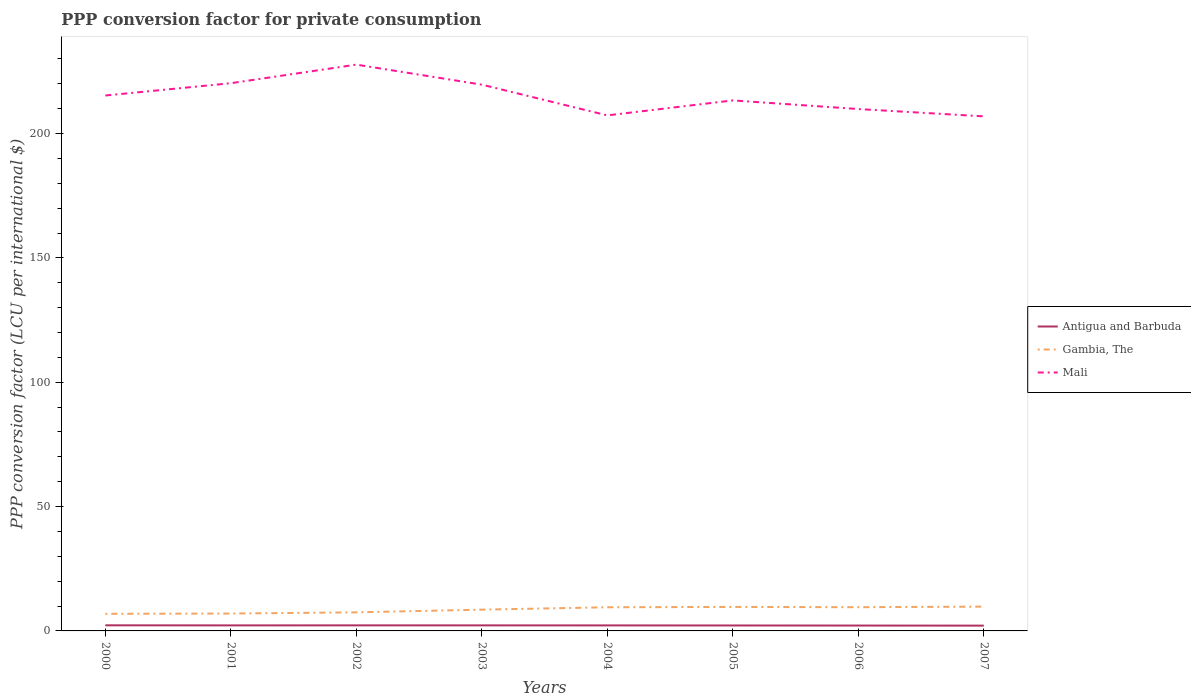Does the line corresponding to Gambia, The intersect with the line corresponding to Antigua and Barbuda?
Your answer should be compact. No. Is the number of lines equal to the number of legend labels?
Your answer should be compact. Yes. Across all years, what is the maximum PPP conversion factor for private consumption in Antigua and Barbuda?
Your answer should be very brief. 2.13. In which year was the PPP conversion factor for private consumption in Mali maximum?
Provide a succinct answer. 2007. What is the total PPP conversion factor for private consumption in Gambia, The in the graph?
Your answer should be very brief. -0.13. What is the difference between the highest and the second highest PPP conversion factor for private consumption in Gambia, The?
Keep it short and to the point. 2.89. What is the difference between two consecutive major ticks on the Y-axis?
Your answer should be very brief. 50. Where does the legend appear in the graph?
Your answer should be compact. Center right. How are the legend labels stacked?
Provide a short and direct response. Vertical. What is the title of the graph?
Offer a very short reply. PPP conversion factor for private consumption. What is the label or title of the X-axis?
Ensure brevity in your answer.  Years. What is the label or title of the Y-axis?
Offer a very short reply. PPP conversion factor (LCU per international $). What is the PPP conversion factor (LCU per international $) of Antigua and Barbuda in 2000?
Your answer should be compact. 2.25. What is the PPP conversion factor (LCU per international $) in Gambia, The in 2000?
Provide a succinct answer. 6.88. What is the PPP conversion factor (LCU per international $) of Mali in 2000?
Your answer should be compact. 215.3. What is the PPP conversion factor (LCU per international $) in Antigua and Barbuda in 2001?
Make the answer very short. 2.22. What is the PPP conversion factor (LCU per international $) in Gambia, The in 2001?
Keep it short and to the point. 6.99. What is the PPP conversion factor (LCU per international $) in Mali in 2001?
Your response must be concise. 220.24. What is the PPP conversion factor (LCU per international $) in Antigua and Barbuda in 2002?
Offer a terse response. 2.24. What is the PPP conversion factor (LCU per international $) in Gambia, The in 2002?
Your answer should be very brief. 7.47. What is the PPP conversion factor (LCU per international $) in Mali in 2002?
Provide a succinct answer. 227.71. What is the PPP conversion factor (LCU per international $) of Antigua and Barbuda in 2003?
Keep it short and to the point. 2.23. What is the PPP conversion factor (LCU per international $) of Gambia, The in 2003?
Provide a short and direct response. 8.55. What is the PPP conversion factor (LCU per international $) in Mali in 2003?
Provide a short and direct response. 219.66. What is the PPP conversion factor (LCU per international $) of Antigua and Barbuda in 2004?
Ensure brevity in your answer.  2.22. What is the PPP conversion factor (LCU per international $) in Gambia, The in 2004?
Provide a succinct answer. 9.51. What is the PPP conversion factor (LCU per international $) of Mali in 2004?
Your answer should be compact. 207.3. What is the PPP conversion factor (LCU per international $) of Antigua and Barbuda in 2005?
Ensure brevity in your answer.  2.19. What is the PPP conversion factor (LCU per international $) in Gambia, The in 2005?
Provide a short and direct response. 9.65. What is the PPP conversion factor (LCU per international $) of Mali in 2005?
Provide a succinct answer. 213.32. What is the PPP conversion factor (LCU per international $) of Antigua and Barbuda in 2006?
Ensure brevity in your answer.  2.16. What is the PPP conversion factor (LCU per international $) in Gambia, The in 2006?
Provide a short and direct response. 9.54. What is the PPP conversion factor (LCU per international $) of Mali in 2006?
Your response must be concise. 209.85. What is the PPP conversion factor (LCU per international $) of Antigua and Barbuda in 2007?
Your response must be concise. 2.13. What is the PPP conversion factor (LCU per international $) of Gambia, The in 2007?
Make the answer very short. 9.77. What is the PPP conversion factor (LCU per international $) in Mali in 2007?
Provide a short and direct response. 206.91. Across all years, what is the maximum PPP conversion factor (LCU per international $) in Antigua and Barbuda?
Make the answer very short. 2.25. Across all years, what is the maximum PPP conversion factor (LCU per international $) in Gambia, The?
Offer a very short reply. 9.77. Across all years, what is the maximum PPP conversion factor (LCU per international $) of Mali?
Offer a terse response. 227.71. Across all years, what is the minimum PPP conversion factor (LCU per international $) in Antigua and Barbuda?
Provide a succinct answer. 2.13. Across all years, what is the minimum PPP conversion factor (LCU per international $) in Gambia, The?
Your answer should be very brief. 6.88. Across all years, what is the minimum PPP conversion factor (LCU per international $) of Mali?
Your answer should be very brief. 206.91. What is the total PPP conversion factor (LCU per international $) of Antigua and Barbuda in the graph?
Ensure brevity in your answer.  17.65. What is the total PPP conversion factor (LCU per international $) of Gambia, The in the graph?
Give a very brief answer. 68.36. What is the total PPP conversion factor (LCU per international $) of Mali in the graph?
Offer a very short reply. 1720.28. What is the difference between the PPP conversion factor (LCU per international $) of Antigua and Barbuda in 2000 and that in 2001?
Ensure brevity in your answer.  0.03. What is the difference between the PPP conversion factor (LCU per international $) of Gambia, The in 2000 and that in 2001?
Ensure brevity in your answer.  -0.11. What is the difference between the PPP conversion factor (LCU per international $) in Mali in 2000 and that in 2001?
Your response must be concise. -4.94. What is the difference between the PPP conversion factor (LCU per international $) in Antigua and Barbuda in 2000 and that in 2002?
Ensure brevity in your answer.  0.01. What is the difference between the PPP conversion factor (LCU per international $) in Gambia, The in 2000 and that in 2002?
Your answer should be compact. -0.59. What is the difference between the PPP conversion factor (LCU per international $) in Mali in 2000 and that in 2002?
Your answer should be compact. -12.42. What is the difference between the PPP conversion factor (LCU per international $) in Antigua and Barbuda in 2000 and that in 2003?
Give a very brief answer. 0.02. What is the difference between the PPP conversion factor (LCU per international $) of Gambia, The in 2000 and that in 2003?
Your answer should be compact. -1.67. What is the difference between the PPP conversion factor (LCU per international $) in Mali in 2000 and that in 2003?
Offer a very short reply. -4.36. What is the difference between the PPP conversion factor (LCU per international $) in Antigua and Barbuda in 2000 and that in 2004?
Provide a short and direct response. 0.03. What is the difference between the PPP conversion factor (LCU per international $) in Gambia, The in 2000 and that in 2004?
Provide a short and direct response. -2.63. What is the difference between the PPP conversion factor (LCU per international $) of Mali in 2000 and that in 2004?
Give a very brief answer. 8. What is the difference between the PPP conversion factor (LCU per international $) in Antigua and Barbuda in 2000 and that in 2005?
Your response must be concise. 0.06. What is the difference between the PPP conversion factor (LCU per international $) in Gambia, The in 2000 and that in 2005?
Make the answer very short. -2.77. What is the difference between the PPP conversion factor (LCU per international $) of Mali in 2000 and that in 2005?
Give a very brief answer. 1.97. What is the difference between the PPP conversion factor (LCU per international $) in Antigua and Barbuda in 2000 and that in 2006?
Keep it short and to the point. 0.09. What is the difference between the PPP conversion factor (LCU per international $) in Gambia, The in 2000 and that in 2006?
Provide a short and direct response. -2.66. What is the difference between the PPP conversion factor (LCU per international $) of Mali in 2000 and that in 2006?
Ensure brevity in your answer.  5.45. What is the difference between the PPP conversion factor (LCU per international $) in Antigua and Barbuda in 2000 and that in 2007?
Offer a terse response. 0.12. What is the difference between the PPP conversion factor (LCU per international $) of Gambia, The in 2000 and that in 2007?
Keep it short and to the point. -2.89. What is the difference between the PPP conversion factor (LCU per international $) in Mali in 2000 and that in 2007?
Ensure brevity in your answer.  8.39. What is the difference between the PPP conversion factor (LCU per international $) in Antigua and Barbuda in 2001 and that in 2002?
Your answer should be very brief. -0.02. What is the difference between the PPP conversion factor (LCU per international $) in Gambia, The in 2001 and that in 2002?
Ensure brevity in your answer.  -0.48. What is the difference between the PPP conversion factor (LCU per international $) of Mali in 2001 and that in 2002?
Your answer should be very brief. -7.47. What is the difference between the PPP conversion factor (LCU per international $) of Antigua and Barbuda in 2001 and that in 2003?
Make the answer very short. -0.01. What is the difference between the PPP conversion factor (LCU per international $) of Gambia, The in 2001 and that in 2003?
Keep it short and to the point. -1.56. What is the difference between the PPP conversion factor (LCU per international $) in Mali in 2001 and that in 2003?
Keep it short and to the point. 0.58. What is the difference between the PPP conversion factor (LCU per international $) of Antigua and Barbuda in 2001 and that in 2004?
Ensure brevity in your answer.  0. What is the difference between the PPP conversion factor (LCU per international $) of Gambia, The in 2001 and that in 2004?
Make the answer very short. -2.52. What is the difference between the PPP conversion factor (LCU per international $) of Mali in 2001 and that in 2004?
Offer a very short reply. 12.94. What is the difference between the PPP conversion factor (LCU per international $) in Antigua and Barbuda in 2001 and that in 2005?
Your answer should be very brief. 0.03. What is the difference between the PPP conversion factor (LCU per international $) of Gambia, The in 2001 and that in 2005?
Your answer should be very brief. -2.66. What is the difference between the PPP conversion factor (LCU per international $) in Mali in 2001 and that in 2005?
Make the answer very short. 6.91. What is the difference between the PPP conversion factor (LCU per international $) of Antigua and Barbuda in 2001 and that in 2006?
Give a very brief answer. 0.06. What is the difference between the PPP conversion factor (LCU per international $) of Gambia, The in 2001 and that in 2006?
Keep it short and to the point. -2.55. What is the difference between the PPP conversion factor (LCU per international $) of Mali in 2001 and that in 2006?
Ensure brevity in your answer.  10.39. What is the difference between the PPP conversion factor (LCU per international $) of Antigua and Barbuda in 2001 and that in 2007?
Your answer should be very brief. 0.09. What is the difference between the PPP conversion factor (LCU per international $) of Gambia, The in 2001 and that in 2007?
Your answer should be compact. -2.78. What is the difference between the PPP conversion factor (LCU per international $) in Mali in 2001 and that in 2007?
Provide a short and direct response. 13.33. What is the difference between the PPP conversion factor (LCU per international $) of Antigua and Barbuda in 2002 and that in 2003?
Keep it short and to the point. 0.01. What is the difference between the PPP conversion factor (LCU per international $) of Gambia, The in 2002 and that in 2003?
Your answer should be compact. -1.08. What is the difference between the PPP conversion factor (LCU per international $) of Mali in 2002 and that in 2003?
Offer a very short reply. 8.05. What is the difference between the PPP conversion factor (LCU per international $) of Antigua and Barbuda in 2002 and that in 2004?
Your answer should be compact. 0.02. What is the difference between the PPP conversion factor (LCU per international $) of Gambia, The in 2002 and that in 2004?
Your answer should be very brief. -2.04. What is the difference between the PPP conversion factor (LCU per international $) of Mali in 2002 and that in 2004?
Your answer should be very brief. 20.41. What is the difference between the PPP conversion factor (LCU per international $) in Antigua and Barbuda in 2002 and that in 2005?
Give a very brief answer. 0.05. What is the difference between the PPP conversion factor (LCU per international $) of Gambia, The in 2002 and that in 2005?
Provide a short and direct response. -2.17. What is the difference between the PPP conversion factor (LCU per international $) in Mali in 2002 and that in 2005?
Give a very brief answer. 14.39. What is the difference between the PPP conversion factor (LCU per international $) in Antigua and Barbuda in 2002 and that in 2006?
Provide a succinct answer. 0.08. What is the difference between the PPP conversion factor (LCU per international $) in Gambia, The in 2002 and that in 2006?
Give a very brief answer. -2.06. What is the difference between the PPP conversion factor (LCU per international $) of Mali in 2002 and that in 2006?
Provide a succinct answer. 17.86. What is the difference between the PPP conversion factor (LCU per international $) of Antigua and Barbuda in 2002 and that in 2007?
Your answer should be very brief. 0.11. What is the difference between the PPP conversion factor (LCU per international $) in Gambia, The in 2002 and that in 2007?
Offer a terse response. -2.3. What is the difference between the PPP conversion factor (LCU per international $) in Mali in 2002 and that in 2007?
Keep it short and to the point. 20.8. What is the difference between the PPP conversion factor (LCU per international $) in Antigua and Barbuda in 2003 and that in 2004?
Your answer should be very brief. 0.01. What is the difference between the PPP conversion factor (LCU per international $) of Gambia, The in 2003 and that in 2004?
Offer a very short reply. -0.96. What is the difference between the PPP conversion factor (LCU per international $) in Mali in 2003 and that in 2004?
Provide a short and direct response. 12.36. What is the difference between the PPP conversion factor (LCU per international $) in Antigua and Barbuda in 2003 and that in 2005?
Provide a succinct answer. 0.04. What is the difference between the PPP conversion factor (LCU per international $) in Gambia, The in 2003 and that in 2005?
Provide a short and direct response. -1.09. What is the difference between the PPP conversion factor (LCU per international $) in Mali in 2003 and that in 2005?
Your answer should be very brief. 6.33. What is the difference between the PPP conversion factor (LCU per international $) in Antigua and Barbuda in 2003 and that in 2006?
Your response must be concise. 0.07. What is the difference between the PPP conversion factor (LCU per international $) of Gambia, The in 2003 and that in 2006?
Make the answer very short. -0.98. What is the difference between the PPP conversion factor (LCU per international $) of Mali in 2003 and that in 2006?
Provide a short and direct response. 9.81. What is the difference between the PPP conversion factor (LCU per international $) in Antigua and Barbuda in 2003 and that in 2007?
Your answer should be compact. 0.1. What is the difference between the PPP conversion factor (LCU per international $) in Gambia, The in 2003 and that in 2007?
Provide a short and direct response. -1.22. What is the difference between the PPP conversion factor (LCU per international $) in Mali in 2003 and that in 2007?
Give a very brief answer. 12.75. What is the difference between the PPP conversion factor (LCU per international $) of Antigua and Barbuda in 2004 and that in 2005?
Ensure brevity in your answer.  0.03. What is the difference between the PPP conversion factor (LCU per international $) of Gambia, The in 2004 and that in 2005?
Provide a short and direct response. -0.13. What is the difference between the PPP conversion factor (LCU per international $) of Mali in 2004 and that in 2005?
Make the answer very short. -6.03. What is the difference between the PPP conversion factor (LCU per international $) of Antigua and Barbuda in 2004 and that in 2006?
Keep it short and to the point. 0.06. What is the difference between the PPP conversion factor (LCU per international $) in Gambia, The in 2004 and that in 2006?
Provide a short and direct response. -0.02. What is the difference between the PPP conversion factor (LCU per international $) of Mali in 2004 and that in 2006?
Make the answer very short. -2.55. What is the difference between the PPP conversion factor (LCU per international $) of Antigua and Barbuda in 2004 and that in 2007?
Give a very brief answer. 0.09. What is the difference between the PPP conversion factor (LCU per international $) of Gambia, The in 2004 and that in 2007?
Keep it short and to the point. -0.26. What is the difference between the PPP conversion factor (LCU per international $) in Mali in 2004 and that in 2007?
Provide a succinct answer. 0.39. What is the difference between the PPP conversion factor (LCU per international $) in Antigua and Barbuda in 2005 and that in 2006?
Ensure brevity in your answer.  0.03. What is the difference between the PPP conversion factor (LCU per international $) of Gambia, The in 2005 and that in 2006?
Provide a succinct answer. 0.11. What is the difference between the PPP conversion factor (LCU per international $) in Mali in 2005 and that in 2006?
Your answer should be compact. 3.48. What is the difference between the PPP conversion factor (LCU per international $) of Antigua and Barbuda in 2005 and that in 2007?
Offer a very short reply. 0.06. What is the difference between the PPP conversion factor (LCU per international $) in Gambia, The in 2005 and that in 2007?
Ensure brevity in your answer.  -0.12. What is the difference between the PPP conversion factor (LCU per international $) of Mali in 2005 and that in 2007?
Your answer should be compact. 6.42. What is the difference between the PPP conversion factor (LCU per international $) in Antigua and Barbuda in 2006 and that in 2007?
Ensure brevity in your answer.  0.03. What is the difference between the PPP conversion factor (LCU per international $) of Gambia, The in 2006 and that in 2007?
Your response must be concise. -0.23. What is the difference between the PPP conversion factor (LCU per international $) in Mali in 2006 and that in 2007?
Give a very brief answer. 2.94. What is the difference between the PPP conversion factor (LCU per international $) in Antigua and Barbuda in 2000 and the PPP conversion factor (LCU per international $) in Gambia, The in 2001?
Offer a very short reply. -4.74. What is the difference between the PPP conversion factor (LCU per international $) of Antigua and Barbuda in 2000 and the PPP conversion factor (LCU per international $) of Mali in 2001?
Offer a terse response. -217.99. What is the difference between the PPP conversion factor (LCU per international $) in Gambia, The in 2000 and the PPP conversion factor (LCU per international $) in Mali in 2001?
Make the answer very short. -213.36. What is the difference between the PPP conversion factor (LCU per international $) of Antigua and Barbuda in 2000 and the PPP conversion factor (LCU per international $) of Gambia, The in 2002?
Your answer should be very brief. -5.22. What is the difference between the PPP conversion factor (LCU per international $) of Antigua and Barbuda in 2000 and the PPP conversion factor (LCU per international $) of Mali in 2002?
Offer a terse response. -225.46. What is the difference between the PPP conversion factor (LCU per international $) of Gambia, The in 2000 and the PPP conversion factor (LCU per international $) of Mali in 2002?
Your response must be concise. -220.83. What is the difference between the PPP conversion factor (LCU per international $) of Antigua and Barbuda in 2000 and the PPP conversion factor (LCU per international $) of Gambia, The in 2003?
Make the answer very short. -6.3. What is the difference between the PPP conversion factor (LCU per international $) of Antigua and Barbuda in 2000 and the PPP conversion factor (LCU per international $) of Mali in 2003?
Give a very brief answer. -217.41. What is the difference between the PPP conversion factor (LCU per international $) of Gambia, The in 2000 and the PPP conversion factor (LCU per international $) of Mali in 2003?
Your response must be concise. -212.78. What is the difference between the PPP conversion factor (LCU per international $) of Antigua and Barbuda in 2000 and the PPP conversion factor (LCU per international $) of Gambia, The in 2004?
Provide a short and direct response. -7.26. What is the difference between the PPP conversion factor (LCU per international $) of Antigua and Barbuda in 2000 and the PPP conversion factor (LCU per international $) of Mali in 2004?
Offer a very short reply. -205.05. What is the difference between the PPP conversion factor (LCU per international $) of Gambia, The in 2000 and the PPP conversion factor (LCU per international $) of Mali in 2004?
Offer a terse response. -200.42. What is the difference between the PPP conversion factor (LCU per international $) in Antigua and Barbuda in 2000 and the PPP conversion factor (LCU per international $) in Gambia, The in 2005?
Offer a terse response. -7.39. What is the difference between the PPP conversion factor (LCU per international $) of Antigua and Barbuda in 2000 and the PPP conversion factor (LCU per international $) of Mali in 2005?
Your answer should be compact. -211.07. What is the difference between the PPP conversion factor (LCU per international $) in Gambia, The in 2000 and the PPP conversion factor (LCU per international $) in Mali in 2005?
Provide a succinct answer. -206.45. What is the difference between the PPP conversion factor (LCU per international $) in Antigua and Barbuda in 2000 and the PPP conversion factor (LCU per international $) in Gambia, The in 2006?
Give a very brief answer. -7.28. What is the difference between the PPP conversion factor (LCU per international $) of Antigua and Barbuda in 2000 and the PPP conversion factor (LCU per international $) of Mali in 2006?
Your response must be concise. -207.6. What is the difference between the PPP conversion factor (LCU per international $) of Gambia, The in 2000 and the PPP conversion factor (LCU per international $) of Mali in 2006?
Keep it short and to the point. -202.97. What is the difference between the PPP conversion factor (LCU per international $) of Antigua and Barbuda in 2000 and the PPP conversion factor (LCU per international $) of Gambia, The in 2007?
Offer a very short reply. -7.52. What is the difference between the PPP conversion factor (LCU per international $) in Antigua and Barbuda in 2000 and the PPP conversion factor (LCU per international $) in Mali in 2007?
Provide a succinct answer. -204.66. What is the difference between the PPP conversion factor (LCU per international $) of Gambia, The in 2000 and the PPP conversion factor (LCU per international $) of Mali in 2007?
Offer a terse response. -200.03. What is the difference between the PPP conversion factor (LCU per international $) of Antigua and Barbuda in 2001 and the PPP conversion factor (LCU per international $) of Gambia, The in 2002?
Your answer should be compact. -5.25. What is the difference between the PPP conversion factor (LCU per international $) in Antigua and Barbuda in 2001 and the PPP conversion factor (LCU per international $) in Mali in 2002?
Your answer should be very brief. -225.49. What is the difference between the PPP conversion factor (LCU per international $) in Gambia, The in 2001 and the PPP conversion factor (LCU per international $) in Mali in 2002?
Ensure brevity in your answer.  -220.72. What is the difference between the PPP conversion factor (LCU per international $) of Antigua and Barbuda in 2001 and the PPP conversion factor (LCU per international $) of Gambia, The in 2003?
Offer a very short reply. -6.33. What is the difference between the PPP conversion factor (LCU per international $) of Antigua and Barbuda in 2001 and the PPP conversion factor (LCU per international $) of Mali in 2003?
Ensure brevity in your answer.  -217.44. What is the difference between the PPP conversion factor (LCU per international $) in Gambia, The in 2001 and the PPP conversion factor (LCU per international $) in Mali in 2003?
Your answer should be very brief. -212.67. What is the difference between the PPP conversion factor (LCU per international $) in Antigua and Barbuda in 2001 and the PPP conversion factor (LCU per international $) in Gambia, The in 2004?
Offer a very short reply. -7.29. What is the difference between the PPP conversion factor (LCU per international $) of Antigua and Barbuda in 2001 and the PPP conversion factor (LCU per international $) of Mali in 2004?
Give a very brief answer. -205.08. What is the difference between the PPP conversion factor (LCU per international $) of Gambia, The in 2001 and the PPP conversion factor (LCU per international $) of Mali in 2004?
Your response must be concise. -200.31. What is the difference between the PPP conversion factor (LCU per international $) of Antigua and Barbuda in 2001 and the PPP conversion factor (LCU per international $) of Gambia, The in 2005?
Keep it short and to the point. -7.42. What is the difference between the PPP conversion factor (LCU per international $) in Antigua and Barbuda in 2001 and the PPP conversion factor (LCU per international $) in Mali in 2005?
Provide a succinct answer. -211.1. What is the difference between the PPP conversion factor (LCU per international $) of Gambia, The in 2001 and the PPP conversion factor (LCU per international $) of Mali in 2005?
Offer a terse response. -206.33. What is the difference between the PPP conversion factor (LCU per international $) of Antigua and Barbuda in 2001 and the PPP conversion factor (LCU per international $) of Gambia, The in 2006?
Provide a succinct answer. -7.32. What is the difference between the PPP conversion factor (LCU per international $) in Antigua and Barbuda in 2001 and the PPP conversion factor (LCU per international $) in Mali in 2006?
Provide a succinct answer. -207.63. What is the difference between the PPP conversion factor (LCU per international $) in Gambia, The in 2001 and the PPP conversion factor (LCU per international $) in Mali in 2006?
Provide a succinct answer. -202.86. What is the difference between the PPP conversion factor (LCU per international $) of Antigua and Barbuda in 2001 and the PPP conversion factor (LCU per international $) of Gambia, The in 2007?
Offer a very short reply. -7.55. What is the difference between the PPP conversion factor (LCU per international $) of Antigua and Barbuda in 2001 and the PPP conversion factor (LCU per international $) of Mali in 2007?
Give a very brief answer. -204.69. What is the difference between the PPP conversion factor (LCU per international $) in Gambia, The in 2001 and the PPP conversion factor (LCU per international $) in Mali in 2007?
Give a very brief answer. -199.92. What is the difference between the PPP conversion factor (LCU per international $) in Antigua and Barbuda in 2002 and the PPP conversion factor (LCU per international $) in Gambia, The in 2003?
Your answer should be very brief. -6.31. What is the difference between the PPP conversion factor (LCU per international $) of Antigua and Barbuda in 2002 and the PPP conversion factor (LCU per international $) of Mali in 2003?
Give a very brief answer. -217.42. What is the difference between the PPP conversion factor (LCU per international $) of Gambia, The in 2002 and the PPP conversion factor (LCU per international $) of Mali in 2003?
Offer a very short reply. -212.18. What is the difference between the PPP conversion factor (LCU per international $) in Antigua and Barbuda in 2002 and the PPP conversion factor (LCU per international $) in Gambia, The in 2004?
Provide a short and direct response. -7.27. What is the difference between the PPP conversion factor (LCU per international $) in Antigua and Barbuda in 2002 and the PPP conversion factor (LCU per international $) in Mali in 2004?
Provide a short and direct response. -205.06. What is the difference between the PPP conversion factor (LCU per international $) in Gambia, The in 2002 and the PPP conversion factor (LCU per international $) in Mali in 2004?
Provide a succinct answer. -199.83. What is the difference between the PPP conversion factor (LCU per international $) in Antigua and Barbuda in 2002 and the PPP conversion factor (LCU per international $) in Gambia, The in 2005?
Your response must be concise. -7.41. What is the difference between the PPP conversion factor (LCU per international $) in Antigua and Barbuda in 2002 and the PPP conversion factor (LCU per international $) in Mali in 2005?
Offer a terse response. -211.09. What is the difference between the PPP conversion factor (LCU per international $) of Gambia, The in 2002 and the PPP conversion factor (LCU per international $) of Mali in 2005?
Offer a terse response. -205.85. What is the difference between the PPP conversion factor (LCU per international $) of Antigua and Barbuda in 2002 and the PPP conversion factor (LCU per international $) of Gambia, The in 2006?
Your response must be concise. -7.3. What is the difference between the PPP conversion factor (LCU per international $) of Antigua and Barbuda in 2002 and the PPP conversion factor (LCU per international $) of Mali in 2006?
Offer a terse response. -207.61. What is the difference between the PPP conversion factor (LCU per international $) of Gambia, The in 2002 and the PPP conversion factor (LCU per international $) of Mali in 2006?
Offer a very short reply. -202.37. What is the difference between the PPP conversion factor (LCU per international $) in Antigua and Barbuda in 2002 and the PPP conversion factor (LCU per international $) in Gambia, The in 2007?
Keep it short and to the point. -7.53. What is the difference between the PPP conversion factor (LCU per international $) in Antigua and Barbuda in 2002 and the PPP conversion factor (LCU per international $) in Mali in 2007?
Keep it short and to the point. -204.67. What is the difference between the PPP conversion factor (LCU per international $) in Gambia, The in 2002 and the PPP conversion factor (LCU per international $) in Mali in 2007?
Offer a terse response. -199.43. What is the difference between the PPP conversion factor (LCU per international $) of Antigua and Barbuda in 2003 and the PPP conversion factor (LCU per international $) of Gambia, The in 2004?
Offer a very short reply. -7.28. What is the difference between the PPP conversion factor (LCU per international $) of Antigua and Barbuda in 2003 and the PPP conversion factor (LCU per international $) of Mali in 2004?
Offer a terse response. -205.07. What is the difference between the PPP conversion factor (LCU per international $) in Gambia, The in 2003 and the PPP conversion factor (LCU per international $) in Mali in 2004?
Provide a short and direct response. -198.75. What is the difference between the PPP conversion factor (LCU per international $) of Antigua and Barbuda in 2003 and the PPP conversion factor (LCU per international $) of Gambia, The in 2005?
Ensure brevity in your answer.  -7.41. What is the difference between the PPP conversion factor (LCU per international $) of Antigua and Barbuda in 2003 and the PPP conversion factor (LCU per international $) of Mali in 2005?
Offer a terse response. -211.09. What is the difference between the PPP conversion factor (LCU per international $) in Gambia, The in 2003 and the PPP conversion factor (LCU per international $) in Mali in 2005?
Your response must be concise. -204.77. What is the difference between the PPP conversion factor (LCU per international $) of Antigua and Barbuda in 2003 and the PPP conversion factor (LCU per international $) of Gambia, The in 2006?
Offer a very short reply. -7.3. What is the difference between the PPP conversion factor (LCU per international $) of Antigua and Barbuda in 2003 and the PPP conversion factor (LCU per international $) of Mali in 2006?
Your response must be concise. -207.61. What is the difference between the PPP conversion factor (LCU per international $) of Gambia, The in 2003 and the PPP conversion factor (LCU per international $) of Mali in 2006?
Your response must be concise. -201.3. What is the difference between the PPP conversion factor (LCU per international $) of Antigua and Barbuda in 2003 and the PPP conversion factor (LCU per international $) of Gambia, The in 2007?
Your answer should be very brief. -7.54. What is the difference between the PPP conversion factor (LCU per international $) of Antigua and Barbuda in 2003 and the PPP conversion factor (LCU per international $) of Mali in 2007?
Give a very brief answer. -204.68. What is the difference between the PPP conversion factor (LCU per international $) of Gambia, The in 2003 and the PPP conversion factor (LCU per international $) of Mali in 2007?
Your answer should be compact. -198.36. What is the difference between the PPP conversion factor (LCU per international $) of Antigua and Barbuda in 2004 and the PPP conversion factor (LCU per international $) of Gambia, The in 2005?
Your answer should be compact. -7.43. What is the difference between the PPP conversion factor (LCU per international $) in Antigua and Barbuda in 2004 and the PPP conversion factor (LCU per international $) in Mali in 2005?
Give a very brief answer. -211.11. What is the difference between the PPP conversion factor (LCU per international $) of Gambia, The in 2004 and the PPP conversion factor (LCU per international $) of Mali in 2005?
Offer a very short reply. -203.81. What is the difference between the PPP conversion factor (LCU per international $) of Antigua and Barbuda in 2004 and the PPP conversion factor (LCU per international $) of Gambia, The in 2006?
Keep it short and to the point. -7.32. What is the difference between the PPP conversion factor (LCU per international $) in Antigua and Barbuda in 2004 and the PPP conversion factor (LCU per international $) in Mali in 2006?
Your answer should be very brief. -207.63. What is the difference between the PPP conversion factor (LCU per international $) in Gambia, The in 2004 and the PPP conversion factor (LCU per international $) in Mali in 2006?
Your answer should be very brief. -200.34. What is the difference between the PPP conversion factor (LCU per international $) of Antigua and Barbuda in 2004 and the PPP conversion factor (LCU per international $) of Gambia, The in 2007?
Your answer should be compact. -7.55. What is the difference between the PPP conversion factor (LCU per international $) in Antigua and Barbuda in 2004 and the PPP conversion factor (LCU per international $) in Mali in 2007?
Give a very brief answer. -204.69. What is the difference between the PPP conversion factor (LCU per international $) of Gambia, The in 2004 and the PPP conversion factor (LCU per international $) of Mali in 2007?
Provide a succinct answer. -197.4. What is the difference between the PPP conversion factor (LCU per international $) in Antigua and Barbuda in 2005 and the PPP conversion factor (LCU per international $) in Gambia, The in 2006?
Keep it short and to the point. -7.34. What is the difference between the PPP conversion factor (LCU per international $) of Antigua and Barbuda in 2005 and the PPP conversion factor (LCU per international $) of Mali in 2006?
Keep it short and to the point. -207.66. What is the difference between the PPP conversion factor (LCU per international $) of Gambia, The in 2005 and the PPP conversion factor (LCU per international $) of Mali in 2006?
Your answer should be compact. -200.2. What is the difference between the PPP conversion factor (LCU per international $) in Antigua and Barbuda in 2005 and the PPP conversion factor (LCU per international $) in Gambia, The in 2007?
Keep it short and to the point. -7.58. What is the difference between the PPP conversion factor (LCU per international $) in Antigua and Barbuda in 2005 and the PPP conversion factor (LCU per international $) in Mali in 2007?
Your response must be concise. -204.72. What is the difference between the PPP conversion factor (LCU per international $) of Gambia, The in 2005 and the PPP conversion factor (LCU per international $) of Mali in 2007?
Offer a terse response. -197.26. What is the difference between the PPP conversion factor (LCU per international $) in Antigua and Barbuda in 2006 and the PPP conversion factor (LCU per international $) in Gambia, The in 2007?
Keep it short and to the point. -7.61. What is the difference between the PPP conversion factor (LCU per international $) in Antigua and Barbuda in 2006 and the PPP conversion factor (LCU per international $) in Mali in 2007?
Give a very brief answer. -204.75. What is the difference between the PPP conversion factor (LCU per international $) of Gambia, The in 2006 and the PPP conversion factor (LCU per international $) of Mali in 2007?
Your answer should be compact. -197.37. What is the average PPP conversion factor (LCU per international $) of Antigua and Barbuda per year?
Your answer should be very brief. 2.21. What is the average PPP conversion factor (LCU per international $) of Gambia, The per year?
Your answer should be compact. 8.54. What is the average PPP conversion factor (LCU per international $) in Mali per year?
Your answer should be very brief. 215.04. In the year 2000, what is the difference between the PPP conversion factor (LCU per international $) in Antigua and Barbuda and PPP conversion factor (LCU per international $) in Gambia, The?
Provide a short and direct response. -4.63. In the year 2000, what is the difference between the PPP conversion factor (LCU per international $) in Antigua and Barbuda and PPP conversion factor (LCU per international $) in Mali?
Offer a terse response. -213.04. In the year 2000, what is the difference between the PPP conversion factor (LCU per international $) in Gambia, The and PPP conversion factor (LCU per international $) in Mali?
Provide a short and direct response. -208.42. In the year 2001, what is the difference between the PPP conversion factor (LCU per international $) in Antigua and Barbuda and PPP conversion factor (LCU per international $) in Gambia, The?
Offer a terse response. -4.77. In the year 2001, what is the difference between the PPP conversion factor (LCU per international $) of Antigua and Barbuda and PPP conversion factor (LCU per international $) of Mali?
Make the answer very short. -218.02. In the year 2001, what is the difference between the PPP conversion factor (LCU per international $) of Gambia, The and PPP conversion factor (LCU per international $) of Mali?
Give a very brief answer. -213.25. In the year 2002, what is the difference between the PPP conversion factor (LCU per international $) in Antigua and Barbuda and PPP conversion factor (LCU per international $) in Gambia, The?
Ensure brevity in your answer.  -5.23. In the year 2002, what is the difference between the PPP conversion factor (LCU per international $) in Antigua and Barbuda and PPP conversion factor (LCU per international $) in Mali?
Offer a terse response. -225.47. In the year 2002, what is the difference between the PPP conversion factor (LCU per international $) of Gambia, The and PPP conversion factor (LCU per international $) of Mali?
Your answer should be very brief. -220.24. In the year 2003, what is the difference between the PPP conversion factor (LCU per international $) of Antigua and Barbuda and PPP conversion factor (LCU per international $) of Gambia, The?
Give a very brief answer. -6.32. In the year 2003, what is the difference between the PPP conversion factor (LCU per international $) of Antigua and Barbuda and PPP conversion factor (LCU per international $) of Mali?
Your answer should be very brief. -217.42. In the year 2003, what is the difference between the PPP conversion factor (LCU per international $) of Gambia, The and PPP conversion factor (LCU per international $) of Mali?
Provide a short and direct response. -211.11. In the year 2004, what is the difference between the PPP conversion factor (LCU per international $) in Antigua and Barbuda and PPP conversion factor (LCU per international $) in Gambia, The?
Offer a terse response. -7.29. In the year 2004, what is the difference between the PPP conversion factor (LCU per international $) in Antigua and Barbuda and PPP conversion factor (LCU per international $) in Mali?
Provide a succinct answer. -205.08. In the year 2004, what is the difference between the PPP conversion factor (LCU per international $) in Gambia, The and PPP conversion factor (LCU per international $) in Mali?
Keep it short and to the point. -197.79. In the year 2005, what is the difference between the PPP conversion factor (LCU per international $) of Antigua and Barbuda and PPP conversion factor (LCU per international $) of Gambia, The?
Your response must be concise. -7.45. In the year 2005, what is the difference between the PPP conversion factor (LCU per international $) in Antigua and Barbuda and PPP conversion factor (LCU per international $) in Mali?
Your response must be concise. -211.13. In the year 2005, what is the difference between the PPP conversion factor (LCU per international $) of Gambia, The and PPP conversion factor (LCU per international $) of Mali?
Your answer should be compact. -203.68. In the year 2006, what is the difference between the PPP conversion factor (LCU per international $) in Antigua and Barbuda and PPP conversion factor (LCU per international $) in Gambia, The?
Ensure brevity in your answer.  -7.38. In the year 2006, what is the difference between the PPP conversion factor (LCU per international $) of Antigua and Barbuda and PPP conversion factor (LCU per international $) of Mali?
Your answer should be compact. -207.69. In the year 2006, what is the difference between the PPP conversion factor (LCU per international $) in Gambia, The and PPP conversion factor (LCU per international $) in Mali?
Provide a short and direct response. -200.31. In the year 2007, what is the difference between the PPP conversion factor (LCU per international $) in Antigua and Barbuda and PPP conversion factor (LCU per international $) in Gambia, The?
Your answer should be very brief. -7.64. In the year 2007, what is the difference between the PPP conversion factor (LCU per international $) in Antigua and Barbuda and PPP conversion factor (LCU per international $) in Mali?
Provide a short and direct response. -204.78. In the year 2007, what is the difference between the PPP conversion factor (LCU per international $) of Gambia, The and PPP conversion factor (LCU per international $) of Mali?
Provide a short and direct response. -197.14. What is the ratio of the PPP conversion factor (LCU per international $) of Gambia, The in 2000 to that in 2001?
Ensure brevity in your answer.  0.98. What is the ratio of the PPP conversion factor (LCU per international $) in Mali in 2000 to that in 2001?
Your response must be concise. 0.98. What is the ratio of the PPP conversion factor (LCU per international $) in Antigua and Barbuda in 2000 to that in 2002?
Your answer should be very brief. 1.01. What is the ratio of the PPP conversion factor (LCU per international $) of Gambia, The in 2000 to that in 2002?
Give a very brief answer. 0.92. What is the ratio of the PPP conversion factor (LCU per international $) in Mali in 2000 to that in 2002?
Provide a succinct answer. 0.95. What is the ratio of the PPP conversion factor (LCU per international $) of Antigua and Barbuda in 2000 to that in 2003?
Offer a very short reply. 1.01. What is the ratio of the PPP conversion factor (LCU per international $) in Gambia, The in 2000 to that in 2003?
Keep it short and to the point. 0.8. What is the ratio of the PPP conversion factor (LCU per international $) of Mali in 2000 to that in 2003?
Give a very brief answer. 0.98. What is the ratio of the PPP conversion factor (LCU per international $) of Antigua and Barbuda in 2000 to that in 2004?
Your answer should be compact. 1.01. What is the ratio of the PPP conversion factor (LCU per international $) of Gambia, The in 2000 to that in 2004?
Give a very brief answer. 0.72. What is the ratio of the PPP conversion factor (LCU per international $) in Mali in 2000 to that in 2004?
Your answer should be very brief. 1.04. What is the ratio of the PPP conversion factor (LCU per international $) in Antigua and Barbuda in 2000 to that in 2005?
Provide a short and direct response. 1.03. What is the ratio of the PPP conversion factor (LCU per international $) in Gambia, The in 2000 to that in 2005?
Your answer should be very brief. 0.71. What is the ratio of the PPP conversion factor (LCU per international $) in Mali in 2000 to that in 2005?
Offer a terse response. 1.01. What is the ratio of the PPP conversion factor (LCU per international $) in Antigua and Barbuda in 2000 to that in 2006?
Make the answer very short. 1.04. What is the ratio of the PPP conversion factor (LCU per international $) in Gambia, The in 2000 to that in 2006?
Keep it short and to the point. 0.72. What is the ratio of the PPP conversion factor (LCU per international $) of Mali in 2000 to that in 2006?
Provide a succinct answer. 1.03. What is the ratio of the PPP conversion factor (LCU per international $) of Antigua and Barbuda in 2000 to that in 2007?
Provide a short and direct response. 1.06. What is the ratio of the PPP conversion factor (LCU per international $) of Gambia, The in 2000 to that in 2007?
Offer a terse response. 0.7. What is the ratio of the PPP conversion factor (LCU per international $) of Mali in 2000 to that in 2007?
Provide a succinct answer. 1.04. What is the ratio of the PPP conversion factor (LCU per international $) of Antigua and Barbuda in 2001 to that in 2002?
Offer a very short reply. 0.99. What is the ratio of the PPP conversion factor (LCU per international $) of Gambia, The in 2001 to that in 2002?
Offer a terse response. 0.94. What is the ratio of the PPP conversion factor (LCU per international $) of Mali in 2001 to that in 2002?
Provide a short and direct response. 0.97. What is the ratio of the PPP conversion factor (LCU per international $) of Antigua and Barbuda in 2001 to that in 2003?
Your answer should be very brief. 0.99. What is the ratio of the PPP conversion factor (LCU per international $) in Gambia, The in 2001 to that in 2003?
Provide a succinct answer. 0.82. What is the ratio of the PPP conversion factor (LCU per international $) of Antigua and Barbuda in 2001 to that in 2004?
Your response must be concise. 1. What is the ratio of the PPP conversion factor (LCU per international $) of Gambia, The in 2001 to that in 2004?
Make the answer very short. 0.73. What is the ratio of the PPP conversion factor (LCU per international $) in Mali in 2001 to that in 2004?
Make the answer very short. 1.06. What is the ratio of the PPP conversion factor (LCU per international $) of Antigua and Barbuda in 2001 to that in 2005?
Your answer should be very brief. 1.01. What is the ratio of the PPP conversion factor (LCU per international $) in Gambia, The in 2001 to that in 2005?
Give a very brief answer. 0.72. What is the ratio of the PPP conversion factor (LCU per international $) of Mali in 2001 to that in 2005?
Keep it short and to the point. 1.03. What is the ratio of the PPP conversion factor (LCU per international $) of Antigua and Barbuda in 2001 to that in 2006?
Offer a very short reply. 1.03. What is the ratio of the PPP conversion factor (LCU per international $) of Gambia, The in 2001 to that in 2006?
Your answer should be very brief. 0.73. What is the ratio of the PPP conversion factor (LCU per international $) in Mali in 2001 to that in 2006?
Your answer should be very brief. 1.05. What is the ratio of the PPP conversion factor (LCU per international $) in Antigua and Barbuda in 2001 to that in 2007?
Offer a very short reply. 1.04. What is the ratio of the PPP conversion factor (LCU per international $) of Gambia, The in 2001 to that in 2007?
Make the answer very short. 0.72. What is the ratio of the PPP conversion factor (LCU per international $) in Mali in 2001 to that in 2007?
Offer a very short reply. 1.06. What is the ratio of the PPP conversion factor (LCU per international $) in Antigua and Barbuda in 2002 to that in 2003?
Your answer should be compact. 1. What is the ratio of the PPP conversion factor (LCU per international $) of Gambia, The in 2002 to that in 2003?
Your answer should be compact. 0.87. What is the ratio of the PPP conversion factor (LCU per international $) in Mali in 2002 to that in 2003?
Provide a succinct answer. 1.04. What is the ratio of the PPP conversion factor (LCU per international $) of Antigua and Barbuda in 2002 to that in 2004?
Your answer should be very brief. 1.01. What is the ratio of the PPP conversion factor (LCU per international $) of Gambia, The in 2002 to that in 2004?
Make the answer very short. 0.79. What is the ratio of the PPP conversion factor (LCU per international $) in Mali in 2002 to that in 2004?
Your answer should be compact. 1.1. What is the ratio of the PPP conversion factor (LCU per international $) of Antigua and Barbuda in 2002 to that in 2005?
Give a very brief answer. 1.02. What is the ratio of the PPP conversion factor (LCU per international $) in Gambia, The in 2002 to that in 2005?
Make the answer very short. 0.77. What is the ratio of the PPP conversion factor (LCU per international $) of Mali in 2002 to that in 2005?
Provide a succinct answer. 1.07. What is the ratio of the PPP conversion factor (LCU per international $) in Antigua and Barbuda in 2002 to that in 2006?
Provide a succinct answer. 1.04. What is the ratio of the PPP conversion factor (LCU per international $) in Gambia, The in 2002 to that in 2006?
Give a very brief answer. 0.78. What is the ratio of the PPP conversion factor (LCU per international $) of Mali in 2002 to that in 2006?
Keep it short and to the point. 1.09. What is the ratio of the PPP conversion factor (LCU per international $) of Antigua and Barbuda in 2002 to that in 2007?
Give a very brief answer. 1.05. What is the ratio of the PPP conversion factor (LCU per international $) in Gambia, The in 2002 to that in 2007?
Make the answer very short. 0.77. What is the ratio of the PPP conversion factor (LCU per international $) in Mali in 2002 to that in 2007?
Offer a terse response. 1.1. What is the ratio of the PPP conversion factor (LCU per international $) in Gambia, The in 2003 to that in 2004?
Your answer should be compact. 0.9. What is the ratio of the PPP conversion factor (LCU per international $) in Mali in 2003 to that in 2004?
Your answer should be very brief. 1.06. What is the ratio of the PPP conversion factor (LCU per international $) of Antigua and Barbuda in 2003 to that in 2005?
Provide a short and direct response. 1.02. What is the ratio of the PPP conversion factor (LCU per international $) of Gambia, The in 2003 to that in 2005?
Keep it short and to the point. 0.89. What is the ratio of the PPP conversion factor (LCU per international $) in Mali in 2003 to that in 2005?
Your response must be concise. 1.03. What is the ratio of the PPP conversion factor (LCU per international $) of Antigua and Barbuda in 2003 to that in 2006?
Ensure brevity in your answer.  1.03. What is the ratio of the PPP conversion factor (LCU per international $) in Gambia, The in 2003 to that in 2006?
Offer a very short reply. 0.9. What is the ratio of the PPP conversion factor (LCU per international $) in Mali in 2003 to that in 2006?
Your answer should be very brief. 1.05. What is the ratio of the PPP conversion factor (LCU per international $) in Antigua and Barbuda in 2003 to that in 2007?
Your answer should be very brief. 1.05. What is the ratio of the PPP conversion factor (LCU per international $) of Gambia, The in 2003 to that in 2007?
Keep it short and to the point. 0.88. What is the ratio of the PPP conversion factor (LCU per international $) of Mali in 2003 to that in 2007?
Keep it short and to the point. 1.06. What is the ratio of the PPP conversion factor (LCU per international $) of Antigua and Barbuda in 2004 to that in 2005?
Your answer should be very brief. 1.01. What is the ratio of the PPP conversion factor (LCU per international $) in Gambia, The in 2004 to that in 2005?
Provide a short and direct response. 0.99. What is the ratio of the PPP conversion factor (LCU per international $) of Mali in 2004 to that in 2005?
Give a very brief answer. 0.97. What is the ratio of the PPP conversion factor (LCU per international $) of Gambia, The in 2004 to that in 2006?
Keep it short and to the point. 1. What is the ratio of the PPP conversion factor (LCU per international $) in Mali in 2004 to that in 2006?
Your response must be concise. 0.99. What is the ratio of the PPP conversion factor (LCU per international $) of Antigua and Barbuda in 2004 to that in 2007?
Provide a short and direct response. 1.04. What is the ratio of the PPP conversion factor (LCU per international $) of Gambia, The in 2004 to that in 2007?
Your answer should be compact. 0.97. What is the ratio of the PPP conversion factor (LCU per international $) in Antigua and Barbuda in 2005 to that in 2006?
Your answer should be very brief. 1.01. What is the ratio of the PPP conversion factor (LCU per international $) of Gambia, The in 2005 to that in 2006?
Your answer should be very brief. 1.01. What is the ratio of the PPP conversion factor (LCU per international $) in Mali in 2005 to that in 2006?
Give a very brief answer. 1.02. What is the ratio of the PPP conversion factor (LCU per international $) in Antigua and Barbuda in 2005 to that in 2007?
Make the answer very short. 1.03. What is the ratio of the PPP conversion factor (LCU per international $) in Gambia, The in 2005 to that in 2007?
Offer a very short reply. 0.99. What is the ratio of the PPP conversion factor (LCU per international $) of Mali in 2005 to that in 2007?
Your response must be concise. 1.03. What is the ratio of the PPP conversion factor (LCU per international $) in Antigua and Barbuda in 2006 to that in 2007?
Provide a short and direct response. 1.01. What is the ratio of the PPP conversion factor (LCU per international $) in Gambia, The in 2006 to that in 2007?
Offer a terse response. 0.98. What is the ratio of the PPP conversion factor (LCU per international $) in Mali in 2006 to that in 2007?
Make the answer very short. 1.01. What is the difference between the highest and the second highest PPP conversion factor (LCU per international $) in Antigua and Barbuda?
Give a very brief answer. 0.01. What is the difference between the highest and the second highest PPP conversion factor (LCU per international $) of Gambia, The?
Provide a succinct answer. 0.12. What is the difference between the highest and the second highest PPP conversion factor (LCU per international $) in Mali?
Offer a terse response. 7.47. What is the difference between the highest and the lowest PPP conversion factor (LCU per international $) in Antigua and Barbuda?
Keep it short and to the point. 0.12. What is the difference between the highest and the lowest PPP conversion factor (LCU per international $) in Gambia, The?
Give a very brief answer. 2.89. What is the difference between the highest and the lowest PPP conversion factor (LCU per international $) in Mali?
Offer a terse response. 20.8. 